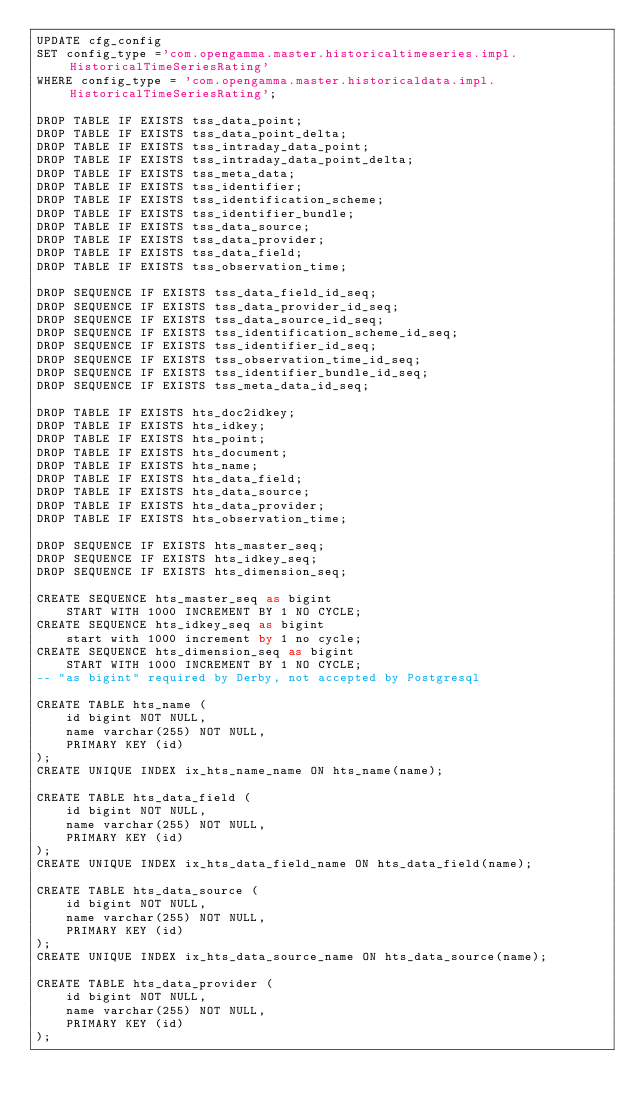Convert code to text. <code><loc_0><loc_0><loc_500><loc_500><_SQL_>UPDATE cfg_config
SET config_type ='com.opengamma.master.historicaltimeseries.impl.HistoricalTimeSeriesRating'
WHERE config_type = 'com.opengamma.master.historicaldata.impl.HistoricalTimeSeriesRating';

DROP TABLE IF EXISTS tss_data_point;
DROP TABLE IF EXISTS tss_data_point_delta;
DROP TABLE IF EXISTS tss_intraday_data_point;
DROP TABLE IF EXISTS tss_intraday_data_point_delta;
DROP TABLE IF EXISTS tss_meta_data;
DROP TABLE IF EXISTS tss_identifier;
DROP TABLE IF EXISTS tss_identification_scheme;
DROP TABLE IF EXISTS tss_identifier_bundle;
DROP TABLE IF EXISTS tss_data_source;
DROP TABLE IF EXISTS tss_data_provider;
DROP TABLE IF EXISTS tss_data_field;
DROP TABLE IF EXISTS tss_observation_time;

DROP SEQUENCE IF EXISTS tss_data_field_id_seq;
DROP SEQUENCE IF EXISTS tss_data_provider_id_seq;
DROP SEQUENCE IF EXISTS tss_data_source_id_seq;
DROP SEQUENCE IF EXISTS tss_identification_scheme_id_seq;
DROP SEQUENCE IF EXISTS tss_identifier_id_seq;
DROP SEQUENCE IF EXISTS tss_observation_time_id_seq;
DROP SEQUENCE IF EXISTS tss_identifier_bundle_id_seq;
DROP SEQUENCE IF EXISTS tss_meta_data_id_seq;

DROP TABLE IF EXISTS hts_doc2idkey;
DROP TABLE IF EXISTS hts_idkey;
DROP TABLE IF EXISTS hts_point;
DROP TABLE IF EXISTS hts_document;
DROP TABLE IF EXISTS hts_name;
DROP TABLE IF EXISTS hts_data_field;
DROP TABLE IF EXISTS hts_data_source;
DROP TABLE IF EXISTS hts_data_provider;
DROP TABLE IF EXISTS hts_observation_time;

DROP SEQUENCE IF EXISTS hts_master_seq;
DROP SEQUENCE IF EXISTS hts_idkey_seq;
DROP SEQUENCE IF EXISTS hts_dimension_seq;

CREATE SEQUENCE hts_master_seq as bigint
    START WITH 1000 INCREMENT BY 1 NO CYCLE;
CREATE SEQUENCE hts_idkey_seq as bigint
    start with 1000 increment by 1 no cycle;
CREATE SEQUENCE hts_dimension_seq as bigint
    START WITH 1000 INCREMENT BY 1 NO CYCLE;
-- "as bigint" required by Derby, not accepted by Postgresql

CREATE TABLE hts_name (
    id bigint NOT NULL,
    name varchar(255) NOT NULL,
    PRIMARY KEY (id)
);
CREATE UNIQUE INDEX ix_hts_name_name ON hts_name(name);

CREATE TABLE hts_data_field (
    id bigint NOT NULL,
    name varchar(255) NOT NULL,
    PRIMARY KEY (id)
);
CREATE UNIQUE INDEX ix_hts_data_field_name ON hts_data_field(name);

CREATE TABLE hts_data_source (
    id bigint NOT NULL,
    name varchar(255) NOT NULL,
    PRIMARY KEY (id)
);
CREATE UNIQUE INDEX ix_hts_data_source_name ON hts_data_source(name);

CREATE TABLE hts_data_provider (
    id bigint NOT NULL,
    name varchar(255) NOT NULL,
    PRIMARY KEY (id)
);</code> 